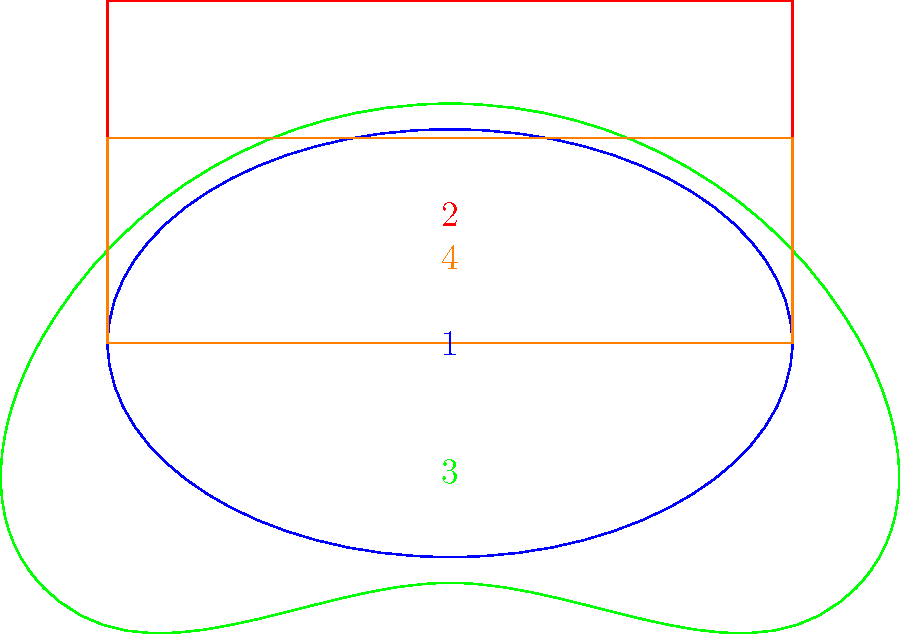Which of the stadium shapes most closely resembles the Allianz Stadion, home of Rapid Wien? To answer this question, we need to analyze the characteristics of each stadium shape and compare them to the Allianz Stadion:

1. Stadium 1 (Blue): This is an elliptical shape, common for athletics stadiums or some older football grounds.

2. Stadium 2 (Red): This is a rectangular shape with sharp corners, typical of older-style football stadiums.

3. Stadium 3 (Green): This shape has curved ends and straight sides, resembling a rounded rectangle or "pill" shape. This is a common modern football stadium design.

4. Stadium 4 (Orange): This is a rectangular shape with slightly rounded corners, a design often used in contemporary football stadiums.

The Allianz Stadion, home of Rapid Wien, was opened in 2016 and features a modern design. It has a rectangular shape with slightly rounded corners, which allows for optimal viewing angles and proximity to the pitch. This description most closely matches Stadium 4 (Orange) in the diagram.

The rounded corners of Stadium 4 provide a more modern look compared to the sharp corners of Stadium 2, while still maintaining the overall rectangular shape that is characteristic of many contemporary football stadiums, including the Allianz Stadion.
Answer: Stadium 4 (Orange) 